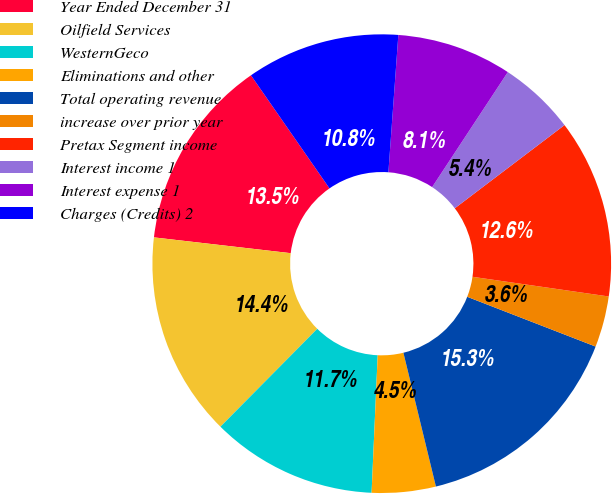<chart> <loc_0><loc_0><loc_500><loc_500><pie_chart><fcel>Year Ended December 31<fcel>Oilfield Services<fcel>WesternGeco<fcel>Eliminations and other<fcel>Total operating revenue<fcel>increase over prior year<fcel>Pretax Segment income<fcel>Interest income 1<fcel>Interest expense 1<fcel>Charges (Credits) 2<nl><fcel>13.51%<fcel>14.41%<fcel>11.71%<fcel>4.5%<fcel>15.32%<fcel>3.6%<fcel>12.61%<fcel>5.41%<fcel>8.11%<fcel>10.81%<nl></chart> 